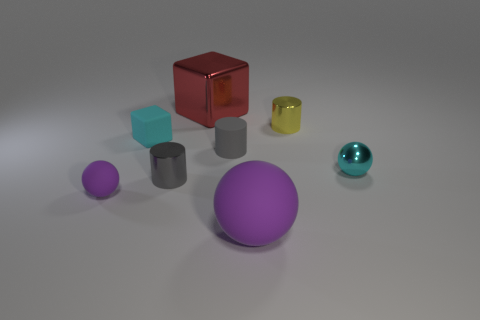Subtract all gray balls. How many gray cylinders are left? 2 Subtract all small balls. How many balls are left? 1 Subtract 1 balls. How many balls are left? 2 Add 2 small cyan balls. How many objects exist? 10 Subtract all cubes. How many objects are left? 6 Add 5 tiny shiny objects. How many tiny shiny objects are left? 8 Add 3 yellow metal cylinders. How many yellow metal cylinders exist? 4 Subtract 0 blue cylinders. How many objects are left? 8 Subtract all big brown balls. Subtract all red shiny objects. How many objects are left? 7 